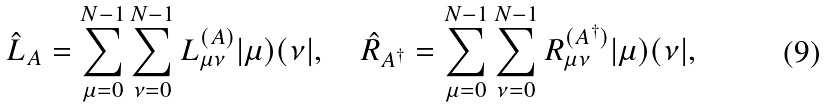Convert formula to latex. <formula><loc_0><loc_0><loc_500><loc_500>\hat { L } _ { A } = \sum ^ { N - 1 } _ { \mu = 0 } \sum ^ { N - 1 } _ { \nu = 0 } L ^ { ( A ) } _ { \mu \nu } | \mu ) ( \nu | , \quad \hat { R } _ { A ^ { \dagger } } = \sum ^ { N - 1 } _ { \mu = 0 } \sum ^ { N - 1 } _ { \nu = 0 } R ^ { ( A ^ { \dagger } ) } _ { \mu \nu } | \mu ) ( \nu | ,</formula> 